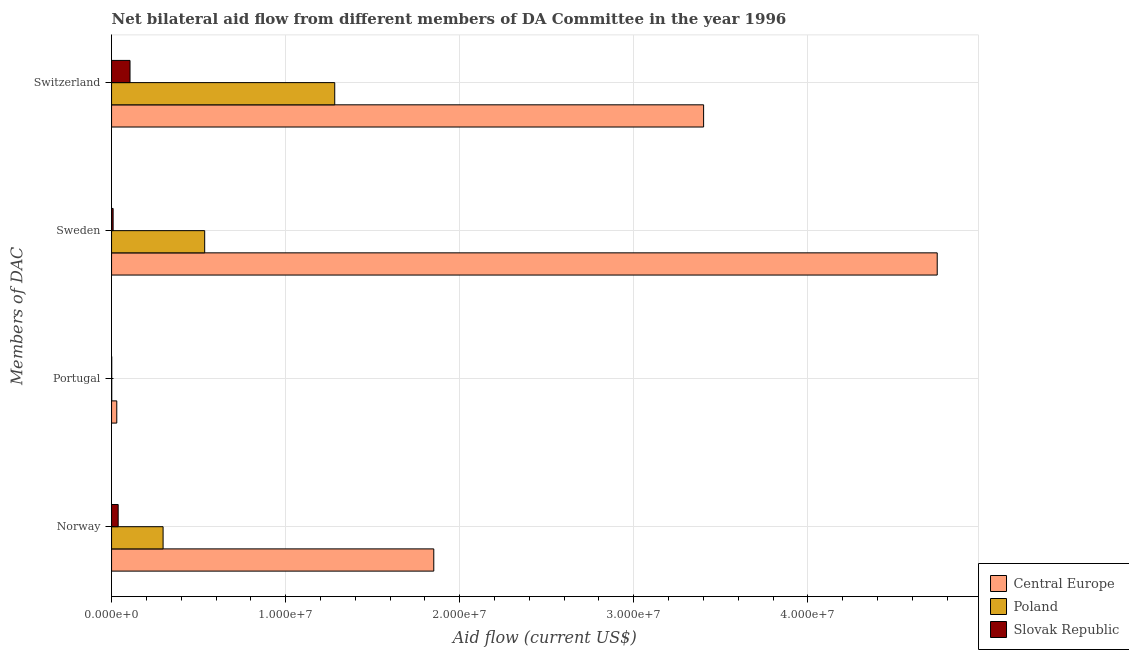Are the number of bars on each tick of the Y-axis equal?
Offer a very short reply. Yes. How many bars are there on the 1st tick from the bottom?
Your answer should be compact. 3. What is the label of the 3rd group of bars from the top?
Offer a terse response. Portugal. What is the amount of aid given by norway in Poland?
Your answer should be very brief. 2.96e+06. Across all countries, what is the maximum amount of aid given by norway?
Make the answer very short. 1.85e+07. Across all countries, what is the minimum amount of aid given by switzerland?
Give a very brief answer. 1.06e+06. In which country was the amount of aid given by portugal maximum?
Your answer should be compact. Central Europe. In which country was the amount of aid given by norway minimum?
Make the answer very short. Slovak Republic. What is the total amount of aid given by switzerland in the graph?
Your answer should be compact. 4.79e+07. What is the difference between the amount of aid given by sweden in Central Europe and that in Poland?
Offer a very short reply. 4.21e+07. What is the difference between the amount of aid given by switzerland in Central Europe and the amount of aid given by sweden in Slovak Republic?
Give a very brief answer. 3.39e+07. What is the average amount of aid given by portugal per country?
Ensure brevity in your answer.  1.07e+05. What is the difference between the amount of aid given by sweden and amount of aid given by switzerland in Slovak Republic?
Your answer should be very brief. -9.70e+05. In how many countries, is the amount of aid given by switzerland greater than 10000000 US$?
Give a very brief answer. 2. What is the ratio of the amount of aid given by sweden in Central Europe to that in Poland?
Ensure brevity in your answer.  8.87. What is the difference between the highest and the second highest amount of aid given by norway?
Provide a succinct answer. 1.56e+07. What is the difference between the highest and the lowest amount of aid given by portugal?
Offer a terse response. 2.90e+05. In how many countries, is the amount of aid given by portugal greater than the average amount of aid given by portugal taken over all countries?
Your answer should be very brief. 1. Is it the case that in every country, the sum of the amount of aid given by portugal and amount of aid given by norway is greater than the sum of amount of aid given by switzerland and amount of aid given by sweden?
Provide a succinct answer. Yes. What does the 2nd bar from the top in Sweden represents?
Your answer should be very brief. Poland. What does the 1st bar from the bottom in Norway represents?
Keep it short and to the point. Central Europe. Is it the case that in every country, the sum of the amount of aid given by norway and amount of aid given by portugal is greater than the amount of aid given by sweden?
Your answer should be very brief. No. How many countries are there in the graph?
Give a very brief answer. 3. What is the title of the graph?
Provide a short and direct response. Net bilateral aid flow from different members of DA Committee in the year 1996. Does "Morocco" appear as one of the legend labels in the graph?
Give a very brief answer. No. What is the label or title of the X-axis?
Offer a very short reply. Aid flow (current US$). What is the label or title of the Y-axis?
Keep it short and to the point. Members of DAC. What is the Aid flow (current US$) in Central Europe in Norway?
Your response must be concise. 1.85e+07. What is the Aid flow (current US$) in Poland in Norway?
Make the answer very short. 2.96e+06. What is the Aid flow (current US$) in Poland in Portugal?
Your answer should be compact. 10000. What is the Aid flow (current US$) in Central Europe in Sweden?
Provide a short and direct response. 4.74e+07. What is the Aid flow (current US$) of Poland in Sweden?
Offer a terse response. 5.35e+06. What is the Aid flow (current US$) in Slovak Republic in Sweden?
Your response must be concise. 9.00e+04. What is the Aid flow (current US$) of Central Europe in Switzerland?
Offer a very short reply. 3.40e+07. What is the Aid flow (current US$) in Poland in Switzerland?
Your answer should be compact. 1.28e+07. What is the Aid flow (current US$) in Slovak Republic in Switzerland?
Offer a very short reply. 1.06e+06. Across all Members of DAC, what is the maximum Aid flow (current US$) of Central Europe?
Ensure brevity in your answer.  4.74e+07. Across all Members of DAC, what is the maximum Aid flow (current US$) of Poland?
Your response must be concise. 1.28e+07. Across all Members of DAC, what is the maximum Aid flow (current US$) of Slovak Republic?
Make the answer very short. 1.06e+06. Across all Members of DAC, what is the minimum Aid flow (current US$) of Central Europe?
Offer a terse response. 3.00e+05. What is the total Aid flow (current US$) in Central Europe in the graph?
Ensure brevity in your answer.  1.00e+08. What is the total Aid flow (current US$) of Poland in the graph?
Your response must be concise. 2.11e+07. What is the total Aid flow (current US$) in Slovak Republic in the graph?
Provide a short and direct response. 1.54e+06. What is the difference between the Aid flow (current US$) in Central Europe in Norway and that in Portugal?
Your answer should be very brief. 1.82e+07. What is the difference between the Aid flow (current US$) in Poland in Norway and that in Portugal?
Keep it short and to the point. 2.95e+06. What is the difference between the Aid flow (current US$) of Central Europe in Norway and that in Sweden?
Offer a very short reply. -2.89e+07. What is the difference between the Aid flow (current US$) of Poland in Norway and that in Sweden?
Offer a very short reply. -2.39e+06. What is the difference between the Aid flow (current US$) in Central Europe in Norway and that in Switzerland?
Your answer should be very brief. -1.55e+07. What is the difference between the Aid flow (current US$) of Poland in Norway and that in Switzerland?
Your answer should be compact. -9.86e+06. What is the difference between the Aid flow (current US$) in Slovak Republic in Norway and that in Switzerland?
Give a very brief answer. -6.80e+05. What is the difference between the Aid flow (current US$) of Central Europe in Portugal and that in Sweden?
Offer a very short reply. -4.71e+07. What is the difference between the Aid flow (current US$) in Poland in Portugal and that in Sweden?
Make the answer very short. -5.34e+06. What is the difference between the Aid flow (current US$) of Central Europe in Portugal and that in Switzerland?
Offer a terse response. -3.37e+07. What is the difference between the Aid flow (current US$) of Poland in Portugal and that in Switzerland?
Ensure brevity in your answer.  -1.28e+07. What is the difference between the Aid flow (current US$) in Slovak Republic in Portugal and that in Switzerland?
Offer a terse response. -1.05e+06. What is the difference between the Aid flow (current US$) of Central Europe in Sweden and that in Switzerland?
Keep it short and to the point. 1.34e+07. What is the difference between the Aid flow (current US$) in Poland in Sweden and that in Switzerland?
Give a very brief answer. -7.47e+06. What is the difference between the Aid flow (current US$) in Slovak Republic in Sweden and that in Switzerland?
Ensure brevity in your answer.  -9.70e+05. What is the difference between the Aid flow (current US$) in Central Europe in Norway and the Aid flow (current US$) in Poland in Portugal?
Make the answer very short. 1.85e+07. What is the difference between the Aid flow (current US$) in Central Europe in Norway and the Aid flow (current US$) in Slovak Republic in Portugal?
Offer a terse response. 1.85e+07. What is the difference between the Aid flow (current US$) of Poland in Norway and the Aid flow (current US$) of Slovak Republic in Portugal?
Ensure brevity in your answer.  2.95e+06. What is the difference between the Aid flow (current US$) in Central Europe in Norway and the Aid flow (current US$) in Poland in Sweden?
Provide a succinct answer. 1.32e+07. What is the difference between the Aid flow (current US$) in Central Europe in Norway and the Aid flow (current US$) in Slovak Republic in Sweden?
Your answer should be very brief. 1.84e+07. What is the difference between the Aid flow (current US$) of Poland in Norway and the Aid flow (current US$) of Slovak Republic in Sweden?
Your response must be concise. 2.87e+06. What is the difference between the Aid flow (current US$) of Central Europe in Norway and the Aid flow (current US$) of Poland in Switzerland?
Your answer should be very brief. 5.69e+06. What is the difference between the Aid flow (current US$) in Central Europe in Norway and the Aid flow (current US$) in Slovak Republic in Switzerland?
Keep it short and to the point. 1.74e+07. What is the difference between the Aid flow (current US$) in Poland in Norway and the Aid flow (current US$) in Slovak Republic in Switzerland?
Provide a succinct answer. 1.90e+06. What is the difference between the Aid flow (current US$) in Central Europe in Portugal and the Aid flow (current US$) in Poland in Sweden?
Your response must be concise. -5.05e+06. What is the difference between the Aid flow (current US$) in Central Europe in Portugal and the Aid flow (current US$) in Slovak Republic in Sweden?
Provide a short and direct response. 2.10e+05. What is the difference between the Aid flow (current US$) of Central Europe in Portugal and the Aid flow (current US$) of Poland in Switzerland?
Provide a short and direct response. -1.25e+07. What is the difference between the Aid flow (current US$) in Central Europe in Portugal and the Aid flow (current US$) in Slovak Republic in Switzerland?
Keep it short and to the point. -7.60e+05. What is the difference between the Aid flow (current US$) in Poland in Portugal and the Aid flow (current US$) in Slovak Republic in Switzerland?
Make the answer very short. -1.05e+06. What is the difference between the Aid flow (current US$) in Central Europe in Sweden and the Aid flow (current US$) in Poland in Switzerland?
Your answer should be very brief. 3.46e+07. What is the difference between the Aid flow (current US$) in Central Europe in Sweden and the Aid flow (current US$) in Slovak Republic in Switzerland?
Your answer should be very brief. 4.64e+07. What is the difference between the Aid flow (current US$) in Poland in Sweden and the Aid flow (current US$) in Slovak Republic in Switzerland?
Ensure brevity in your answer.  4.29e+06. What is the average Aid flow (current US$) in Central Europe per Members of DAC?
Provide a short and direct response. 2.51e+07. What is the average Aid flow (current US$) in Poland per Members of DAC?
Your answer should be compact. 5.28e+06. What is the average Aid flow (current US$) of Slovak Republic per Members of DAC?
Ensure brevity in your answer.  3.85e+05. What is the difference between the Aid flow (current US$) in Central Europe and Aid flow (current US$) in Poland in Norway?
Your response must be concise. 1.56e+07. What is the difference between the Aid flow (current US$) in Central Europe and Aid flow (current US$) in Slovak Republic in Norway?
Your answer should be very brief. 1.81e+07. What is the difference between the Aid flow (current US$) of Poland and Aid flow (current US$) of Slovak Republic in Norway?
Give a very brief answer. 2.58e+06. What is the difference between the Aid flow (current US$) of Central Europe and Aid flow (current US$) of Poland in Portugal?
Offer a very short reply. 2.90e+05. What is the difference between the Aid flow (current US$) of Central Europe and Aid flow (current US$) of Slovak Republic in Portugal?
Offer a very short reply. 2.90e+05. What is the difference between the Aid flow (current US$) of Poland and Aid flow (current US$) of Slovak Republic in Portugal?
Provide a short and direct response. 0. What is the difference between the Aid flow (current US$) in Central Europe and Aid flow (current US$) in Poland in Sweden?
Give a very brief answer. 4.21e+07. What is the difference between the Aid flow (current US$) of Central Europe and Aid flow (current US$) of Slovak Republic in Sweden?
Offer a very short reply. 4.73e+07. What is the difference between the Aid flow (current US$) of Poland and Aid flow (current US$) of Slovak Republic in Sweden?
Ensure brevity in your answer.  5.26e+06. What is the difference between the Aid flow (current US$) of Central Europe and Aid flow (current US$) of Poland in Switzerland?
Your answer should be very brief. 2.12e+07. What is the difference between the Aid flow (current US$) in Central Europe and Aid flow (current US$) in Slovak Republic in Switzerland?
Your response must be concise. 3.30e+07. What is the difference between the Aid flow (current US$) in Poland and Aid flow (current US$) in Slovak Republic in Switzerland?
Your answer should be very brief. 1.18e+07. What is the ratio of the Aid flow (current US$) in Central Europe in Norway to that in Portugal?
Your answer should be very brief. 61.7. What is the ratio of the Aid flow (current US$) in Poland in Norway to that in Portugal?
Give a very brief answer. 296. What is the ratio of the Aid flow (current US$) of Central Europe in Norway to that in Sweden?
Offer a very short reply. 0.39. What is the ratio of the Aid flow (current US$) in Poland in Norway to that in Sweden?
Offer a terse response. 0.55. What is the ratio of the Aid flow (current US$) of Slovak Republic in Norway to that in Sweden?
Offer a very short reply. 4.22. What is the ratio of the Aid flow (current US$) in Central Europe in Norway to that in Switzerland?
Provide a succinct answer. 0.54. What is the ratio of the Aid flow (current US$) of Poland in Norway to that in Switzerland?
Ensure brevity in your answer.  0.23. What is the ratio of the Aid flow (current US$) in Slovak Republic in Norway to that in Switzerland?
Provide a succinct answer. 0.36. What is the ratio of the Aid flow (current US$) of Central Europe in Portugal to that in Sweden?
Give a very brief answer. 0.01. What is the ratio of the Aid flow (current US$) of Poland in Portugal to that in Sweden?
Your answer should be very brief. 0. What is the ratio of the Aid flow (current US$) of Central Europe in Portugal to that in Switzerland?
Your answer should be very brief. 0.01. What is the ratio of the Aid flow (current US$) of Poland in Portugal to that in Switzerland?
Make the answer very short. 0. What is the ratio of the Aid flow (current US$) in Slovak Republic in Portugal to that in Switzerland?
Your answer should be very brief. 0.01. What is the ratio of the Aid flow (current US$) of Central Europe in Sweden to that in Switzerland?
Provide a short and direct response. 1.39. What is the ratio of the Aid flow (current US$) in Poland in Sweden to that in Switzerland?
Provide a short and direct response. 0.42. What is the ratio of the Aid flow (current US$) of Slovak Republic in Sweden to that in Switzerland?
Offer a terse response. 0.08. What is the difference between the highest and the second highest Aid flow (current US$) of Central Europe?
Offer a terse response. 1.34e+07. What is the difference between the highest and the second highest Aid flow (current US$) in Poland?
Provide a succinct answer. 7.47e+06. What is the difference between the highest and the second highest Aid flow (current US$) in Slovak Republic?
Your answer should be compact. 6.80e+05. What is the difference between the highest and the lowest Aid flow (current US$) in Central Europe?
Give a very brief answer. 4.71e+07. What is the difference between the highest and the lowest Aid flow (current US$) in Poland?
Your answer should be very brief. 1.28e+07. What is the difference between the highest and the lowest Aid flow (current US$) of Slovak Republic?
Give a very brief answer. 1.05e+06. 